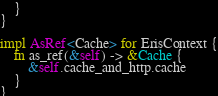<code> <loc_0><loc_0><loc_500><loc_500><_Rust_>    }
}

impl AsRef<Cache> for ErisContext {
    fn as_ref(&self) -> &Cache {
        &self.cache_and_http.cache
    }
}
</code> 